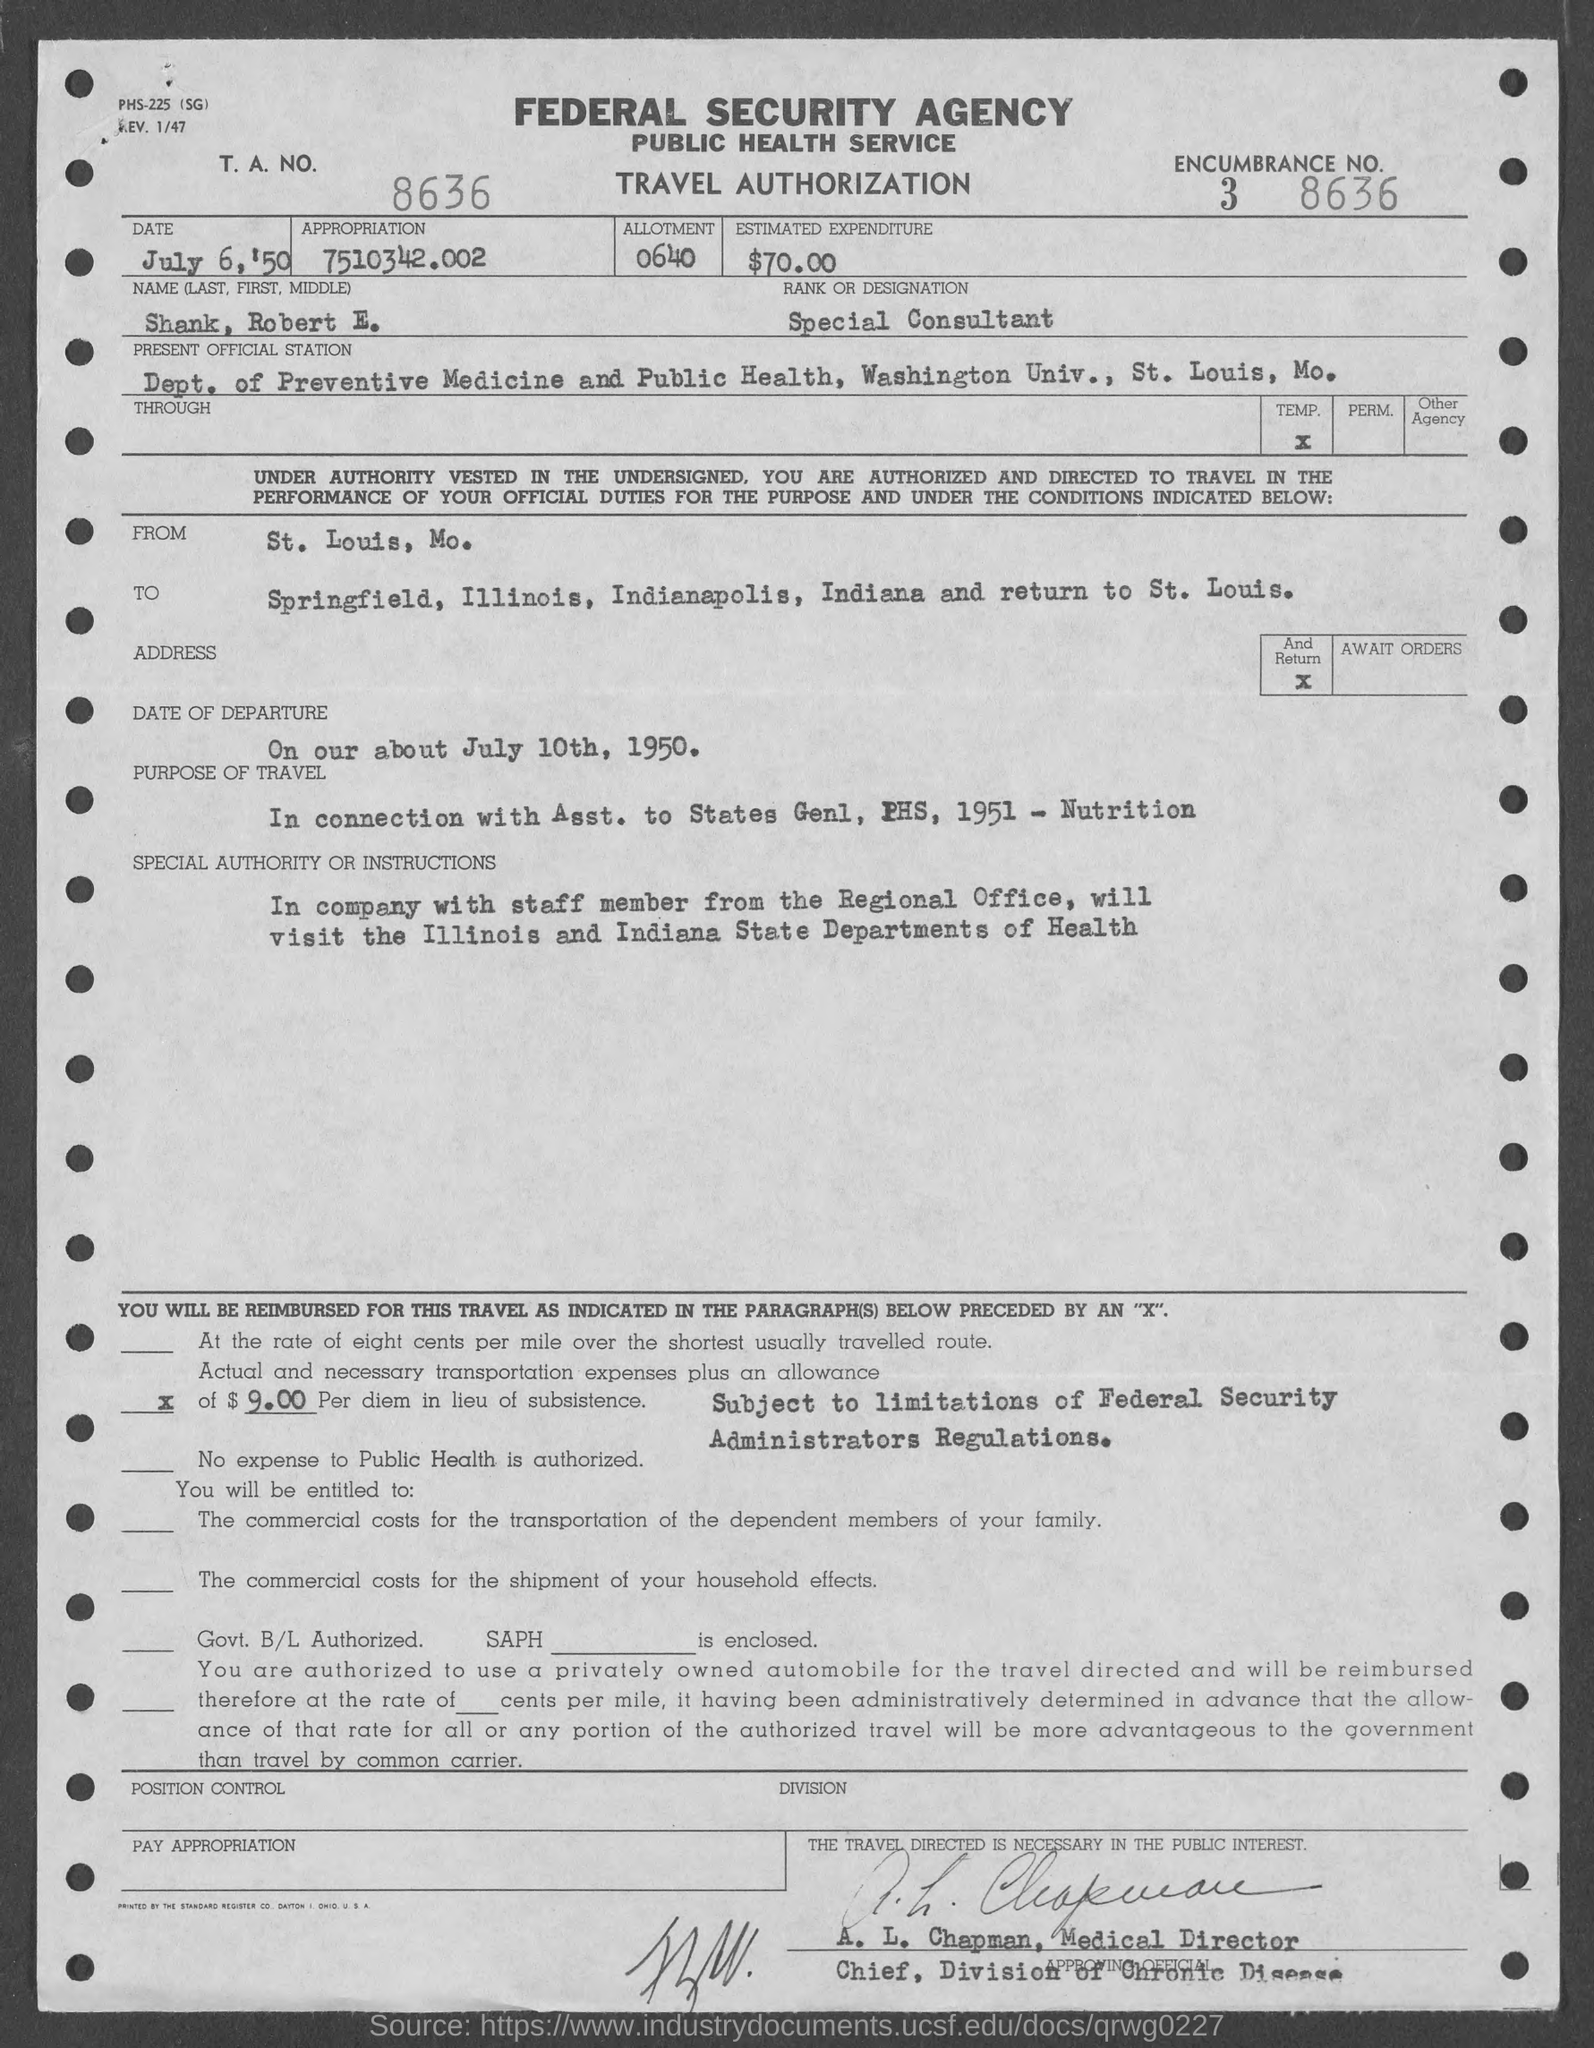Identify some key points in this picture. What is the T.A.N. number? The form is about obtaining travel authorization. The appropriation specified is 7510342.002... The estimated expenditure is approximately $70.00. The date of departure is July 10th, 1950. 